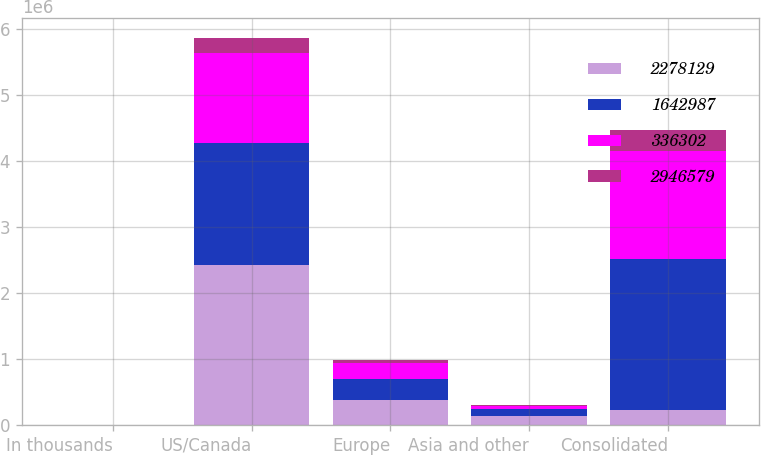Convert chart. <chart><loc_0><loc_0><loc_500><loc_500><stacked_bar_chart><ecel><fcel>In thousands<fcel>US/Canada<fcel>Europe<fcel>Asia and other<fcel>Consolidated<nl><fcel>2.27813e+06<fcel>2005<fcel>2.42393e+06<fcel>378418<fcel>144227<fcel>235021<nl><fcel>1.64299e+06<fcel>2004<fcel>1.85822e+06<fcel>319285<fcel>100620<fcel>2.27813e+06<nl><fcel>336302<fcel>2003<fcel>1.35828e+06<fcel>239102<fcel>45608<fcel>1.64299e+06<nl><fcel>2.94658e+06<fcel>2005<fcel>235021<fcel>53701<fcel>23117<fcel>311839<nl></chart> 